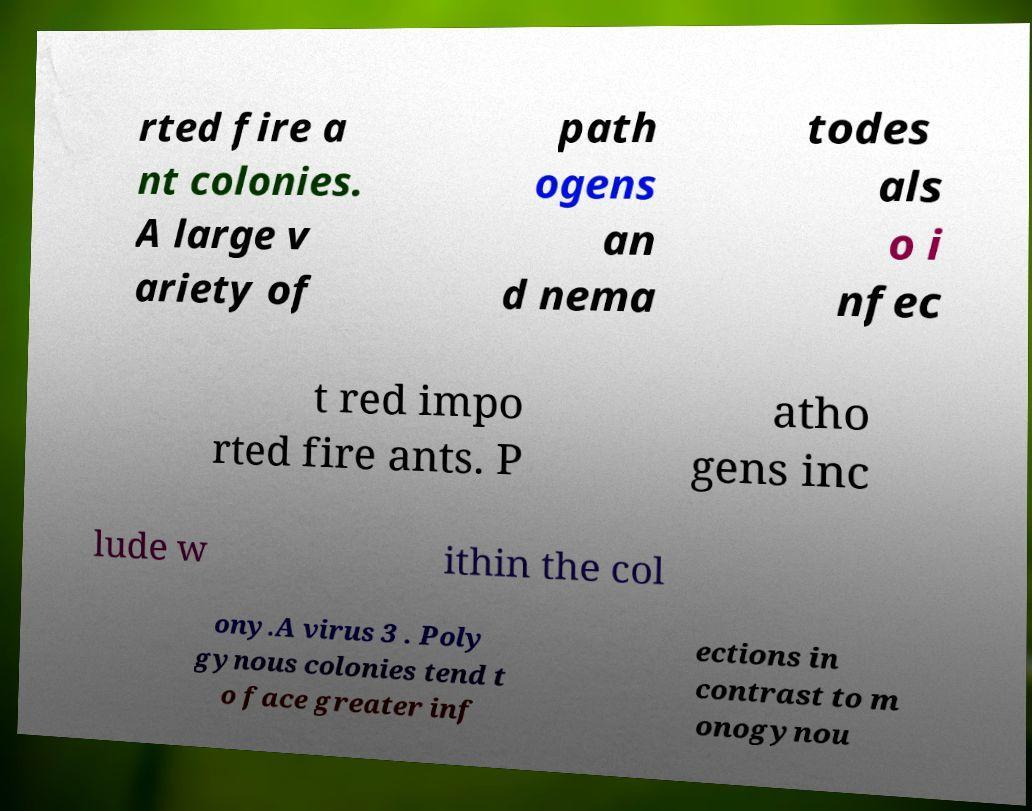What messages or text are displayed in this image? I need them in a readable, typed format. rted fire a nt colonies. A large v ariety of path ogens an d nema todes als o i nfec t red impo rted fire ants. P atho gens inc lude w ithin the col ony.A virus 3 . Poly gynous colonies tend t o face greater inf ections in contrast to m onogynou 